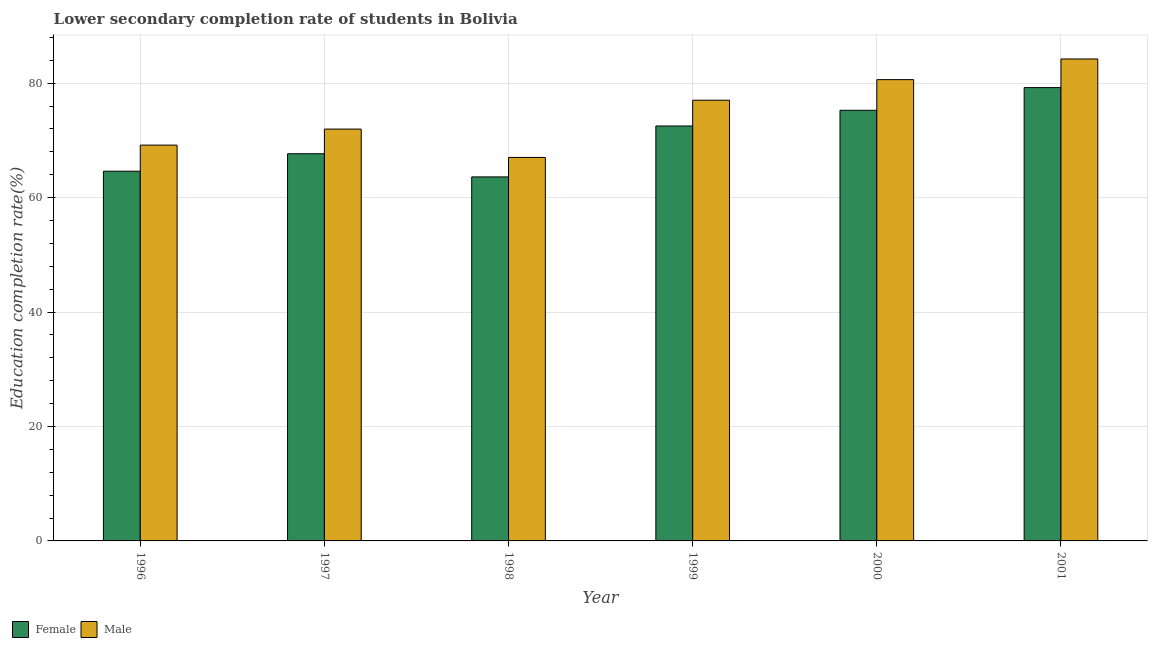Are the number of bars per tick equal to the number of legend labels?
Offer a very short reply. Yes. Are the number of bars on each tick of the X-axis equal?
Offer a terse response. Yes. How many bars are there on the 1st tick from the left?
Give a very brief answer. 2. How many bars are there on the 1st tick from the right?
Your answer should be compact. 2. What is the label of the 4th group of bars from the left?
Your response must be concise. 1999. In how many cases, is the number of bars for a given year not equal to the number of legend labels?
Your answer should be very brief. 0. What is the education completion rate of female students in 2001?
Your answer should be compact. 79.23. Across all years, what is the maximum education completion rate of male students?
Give a very brief answer. 84.23. Across all years, what is the minimum education completion rate of male students?
Your answer should be compact. 67.03. What is the total education completion rate of female students in the graph?
Ensure brevity in your answer.  422.91. What is the difference between the education completion rate of female students in 1998 and that in 2000?
Give a very brief answer. -11.64. What is the difference between the education completion rate of male students in 2001 and the education completion rate of female students in 2000?
Offer a very short reply. 3.61. What is the average education completion rate of male students per year?
Provide a succinct answer. 75.01. In how many years, is the education completion rate of male students greater than 48 %?
Your answer should be compact. 6. What is the ratio of the education completion rate of female students in 1998 to that in 1999?
Keep it short and to the point. 0.88. What is the difference between the highest and the second highest education completion rate of female students?
Keep it short and to the point. 3.96. What is the difference between the highest and the lowest education completion rate of female students?
Provide a succinct answer. 15.61. Is the sum of the education completion rate of female students in 2000 and 2001 greater than the maximum education completion rate of male students across all years?
Ensure brevity in your answer.  Yes. What does the 2nd bar from the left in 2001 represents?
Your answer should be compact. Male. How many bars are there?
Keep it short and to the point. 12. Are all the bars in the graph horizontal?
Offer a very short reply. No. How many years are there in the graph?
Your answer should be compact. 6. Are the values on the major ticks of Y-axis written in scientific E-notation?
Offer a terse response. No. Does the graph contain any zero values?
Keep it short and to the point. No. Does the graph contain grids?
Your answer should be very brief. Yes. Where does the legend appear in the graph?
Your answer should be very brief. Bottom left. How many legend labels are there?
Keep it short and to the point. 2. How are the legend labels stacked?
Give a very brief answer. Horizontal. What is the title of the graph?
Make the answer very short. Lower secondary completion rate of students in Bolivia. Does "Foreign liabilities" appear as one of the legend labels in the graph?
Keep it short and to the point. No. What is the label or title of the Y-axis?
Ensure brevity in your answer.  Education completion rate(%). What is the Education completion rate(%) in Female in 1996?
Provide a succinct answer. 64.61. What is the Education completion rate(%) in Male in 1996?
Offer a very short reply. 69.18. What is the Education completion rate(%) in Female in 1997?
Give a very brief answer. 67.67. What is the Education completion rate(%) in Male in 1997?
Provide a short and direct response. 71.98. What is the Education completion rate(%) of Female in 1998?
Offer a very short reply. 63.62. What is the Education completion rate(%) in Male in 1998?
Ensure brevity in your answer.  67.03. What is the Education completion rate(%) in Female in 1999?
Ensure brevity in your answer.  72.52. What is the Education completion rate(%) of Male in 1999?
Your answer should be very brief. 77.02. What is the Education completion rate(%) of Female in 2000?
Make the answer very short. 75.26. What is the Education completion rate(%) of Male in 2000?
Make the answer very short. 80.62. What is the Education completion rate(%) of Female in 2001?
Offer a very short reply. 79.23. What is the Education completion rate(%) of Male in 2001?
Make the answer very short. 84.23. Across all years, what is the maximum Education completion rate(%) in Female?
Ensure brevity in your answer.  79.23. Across all years, what is the maximum Education completion rate(%) of Male?
Offer a very short reply. 84.23. Across all years, what is the minimum Education completion rate(%) in Female?
Your answer should be very brief. 63.62. Across all years, what is the minimum Education completion rate(%) in Male?
Your answer should be compact. 67.03. What is the total Education completion rate(%) of Female in the graph?
Your response must be concise. 422.91. What is the total Education completion rate(%) in Male in the graph?
Offer a very short reply. 450.05. What is the difference between the Education completion rate(%) in Female in 1996 and that in 1997?
Your response must be concise. -3.05. What is the difference between the Education completion rate(%) of Male in 1996 and that in 1997?
Give a very brief answer. -2.8. What is the difference between the Education completion rate(%) of Male in 1996 and that in 1998?
Offer a very short reply. 2.15. What is the difference between the Education completion rate(%) of Female in 1996 and that in 1999?
Provide a succinct answer. -7.9. What is the difference between the Education completion rate(%) in Male in 1996 and that in 1999?
Your response must be concise. -7.85. What is the difference between the Education completion rate(%) in Female in 1996 and that in 2000?
Provide a succinct answer. -10.65. What is the difference between the Education completion rate(%) of Male in 1996 and that in 2000?
Offer a terse response. -11.45. What is the difference between the Education completion rate(%) in Female in 1996 and that in 2001?
Provide a short and direct response. -14.61. What is the difference between the Education completion rate(%) of Male in 1996 and that in 2001?
Your answer should be compact. -15.06. What is the difference between the Education completion rate(%) in Female in 1997 and that in 1998?
Your response must be concise. 4.05. What is the difference between the Education completion rate(%) of Male in 1997 and that in 1998?
Your answer should be compact. 4.95. What is the difference between the Education completion rate(%) of Female in 1997 and that in 1999?
Provide a succinct answer. -4.85. What is the difference between the Education completion rate(%) in Male in 1997 and that in 1999?
Ensure brevity in your answer.  -5.05. What is the difference between the Education completion rate(%) of Female in 1997 and that in 2000?
Provide a short and direct response. -7.59. What is the difference between the Education completion rate(%) of Male in 1997 and that in 2000?
Provide a succinct answer. -8.64. What is the difference between the Education completion rate(%) in Female in 1997 and that in 2001?
Make the answer very short. -11.56. What is the difference between the Education completion rate(%) in Male in 1997 and that in 2001?
Ensure brevity in your answer.  -12.25. What is the difference between the Education completion rate(%) of Female in 1998 and that in 1999?
Make the answer very short. -8.9. What is the difference between the Education completion rate(%) of Male in 1998 and that in 1999?
Offer a terse response. -10. What is the difference between the Education completion rate(%) in Female in 1998 and that in 2000?
Ensure brevity in your answer.  -11.64. What is the difference between the Education completion rate(%) of Male in 1998 and that in 2000?
Make the answer very short. -13.6. What is the difference between the Education completion rate(%) in Female in 1998 and that in 2001?
Provide a succinct answer. -15.61. What is the difference between the Education completion rate(%) of Male in 1998 and that in 2001?
Ensure brevity in your answer.  -17.21. What is the difference between the Education completion rate(%) in Female in 1999 and that in 2000?
Provide a short and direct response. -2.74. What is the difference between the Education completion rate(%) in Male in 1999 and that in 2000?
Provide a succinct answer. -3.6. What is the difference between the Education completion rate(%) in Female in 1999 and that in 2001?
Offer a very short reply. -6.71. What is the difference between the Education completion rate(%) in Male in 1999 and that in 2001?
Your response must be concise. -7.21. What is the difference between the Education completion rate(%) of Female in 2000 and that in 2001?
Offer a terse response. -3.96. What is the difference between the Education completion rate(%) in Male in 2000 and that in 2001?
Make the answer very short. -3.61. What is the difference between the Education completion rate(%) of Female in 1996 and the Education completion rate(%) of Male in 1997?
Provide a succinct answer. -7.36. What is the difference between the Education completion rate(%) of Female in 1996 and the Education completion rate(%) of Male in 1998?
Make the answer very short. -2.41. What is the difference between the Education completion rate(%) in Female in 1996 and the Education completion rate(%) in Male in 1999?
Give a very brief answer. -12.41. What is the difference between the Education completion rate(%) of Female in 1996 and the Education completion rate(%) of Male in 2000?
Provide a succinct answer. -16.01. What is the difference between the Education completion rate(%) of Female in 1996 and the Education completion rate(%) of Male in 2001?
Offer a very short reply. -19.62. What is the difference between the Education completion rate(%) of Female in 1997 and the Education completion rate(%) of Male in 1998?
Provide a short and direct response. 0.64. What is the difference between the Education completion rate(%) in Female in 1997 and the Education completion rate(%) in Male in 1999?
Ensure brevity in your answer.  -9.36. What is the difference between the Education completion rate(%) of Female in 1997 and the Education completion rate(%) of Male in 2000?
Offer a very short reply. -12.95. What is the difference between the Education completion rate(%) in Female in 1997 and the Education completion rate(%) in Male in 2001?
Offer a terse response. -16.56. What is the difference between the Education completion rate(%) of Female in 1998 and the Education completion rate(%) of Male in 1999?
Offer a very short reply. -13.41. What is the difference between the Education completion rate(%) of Female in 1998 and the Education completion rate(%) of Male in 2000?
Ensure brevity in your answer.  -17. What is the difference between the Education completion rate(%) in Female in 1998 and the Education completion rate(%) in Male in 2001?
Offer a terse response. -20.61. What is the difference between the Education completion rate(%) of Female in 1999 and the Education completion rate(%) of Male in 2000?
Ensure brevity in your answer.  -8.1. What is the difference between the Education completion rate(%) of Female in 1999 and the Education completion rate(%) of Male in 2001?
Make the answer very short. -11.71. What is the difference between the Education completion rate(%) of Female in 2000 and the Education completion rate(%) of Male in 2001?
Provide a succinct answer. -8.97. What is the average Education completion rate(%) in Female per year?
Provide a short and direct response. 70.48. What is the average Education completion rate(%) in Male per year?
Offer a terse response. 75.01. In the year 1996, what is the difference between the Education completion rate(%) in Female and Education completion rate(%) in Male?
Ensure brevity in your answer.  -4.56. In the year 1997, what is the difference between the Education completion rate(%) in Female and Education completion rate(%) in Male?
Give a very brief answer. -4.31. In the year 1998, what is the difference between the Education completion rate(%) of Female and Education completion rate(%) of Male?
Keep it short and to the point. -3.41. In the year 1999, what is the difference between the Education completion rate(%) in Female and Education completion rate(%) in Male?
Provide a succinct answer. -4.51. In the year 2000, what is the difference between the Education completion rate(%) in Female and Education completion rate(%) in Male?
Your response must be concise. -5.36. In the year 2001, what is the difference between the Education completion rate(%) in Female and Education completion rate(%) in Male?
Keep it short and to the point. -5. What is the ratio of the Education completion rate(%) of Female in 1996 to that in 1997?
Your answer should be very brief. 0.95. What is the ratio of the Education completion rate(%) of Male in 1996 to that in 1997?
Your answer should be compact. 0.96. What is the ratio of the Education completion rate(%) of Female in 1996 to that in 1998?
Ensure brevity in your answer.  1.02. What is the ratio of the Education completion rate(%) of Male in 1996 to that in 1998?
Give a very brief answer. 1.03. What is the ratio of the Education completion rate(%) in Female in 1996 to that in 1999?
Ensure brevity in your answer.  0.89. What is the ratio of the Education completion rate(%) in Male in 1996 to that in 1999?
Your answer should be compact. 0.9. What is the ratio of the Education completion rate(%) of Female in 1996 to that in 2000?
Provide a short and direct response. 0.86. What is the ratio of the Education completion rate(%) of Male in 1996 to that in 2000?
Offer a terse response. 0.86. What is the ratio of the Education completion rate(%) of Female in 1996 to that in 2001?
Make the answer very short. 0.82. What is the ratio of the Education completion rate(%) of Male in 1996 to that in 2001?
Your response must be concise. 0.82. What is the ratio of the Education completion rate(%) in Female in 1997 to that in 1998?
Ensure brevity in your answer.  1.06. What is the ratio of the Education completion rate(%) in Male in 1997 to that in 1998?
Offer a very short reply. 1.07. What is the ratio of the Education completion rate(%) of Female in 1997 to that in 1999?
Your answer should be very brief. 0.93. What is the ratio of the Education completion rate(%) of Male in 1997 to that in 1999?
Offer a terse response. 0.93. What is the ratio of the Education completion rate(%) in Female in 1997 to that in 2000?
Give a very brief answer. 0.9. What is the ratio of the Education completion rate(%) of Male in 1997 to that in 2000?
Provide a succinct answer. 0.89. What is the ratio of the Education completion rate(%) of Female in 1997 to that in 2001?
Your answer should be compact. 0.85. What is the ratio of the Education completion rate(%) in Male in 1997 to that in 2001?
Your answer should be very brief. 0.85. What is the ratio of the Education completion rate(%) in Female in 1998 to that in 1999?
Provide a short and direct response. 0.88. What is the ratio of the Education completion rate(%) of Male in 1998 to that in 1999?
Ensure brevity in your answer.  0.87. What is the ratio of the Education completion rate(%) in Female in 1998 to that in 2000?
Provide a succinct answer. 0.85. What is the ratio of the Education completion rate(%) in Male in 1998 to that in 2000?
Your answer should be compact. 0.83. What is the ratio of the Education completion rate(%) of Female in 1998 to that in 2001?
Give a very brief answer. 0.8. What is the ratio of the Education completion rate(%) of Male in 1998 to that in 2001?
Keep it short and to the point. 0.8. What is the ratio of the Education completion rate(%) in Female in 1999 to that in 2000?
Provide a succinct answer. 0.96. What is the ratio of the Education completion rate(%) of Male in 1999 to that in 2000?
Your answer should be compact. 0.96. What is the ratio of the Education completion rate(%) in Female in 1999 to that in 2001?
Make the answer very short. 0.92. What is the ratio of the Education completion rate(%) in Male in 1999 to that in 2001?
Your answer should be very brief. 0.91. What is the ratio of the Education completion rate(%) in Female in 2000 to that in 2001?
Provide a short and direct response. 0.95. What is the ratio of the Education completion rate(%) of Male in 2000 to that in 2001?
Offer a very short reply. 0.96. What is the difference between the highest and the second highest Education completion rate(%) of Female?
Make the answer very short. 3.96. What is the difference between the highest and the second highest Education completion rate(%) in Male?
Make the answer very short. 3.61. What is the difference between the highest and the lowest Education completion rate(%) of Female?
Make the answer very short. 15.61. What is the difference between the highest and the lowest Education completion rate(%) in Male?
Make the answer very short. 17.21. 